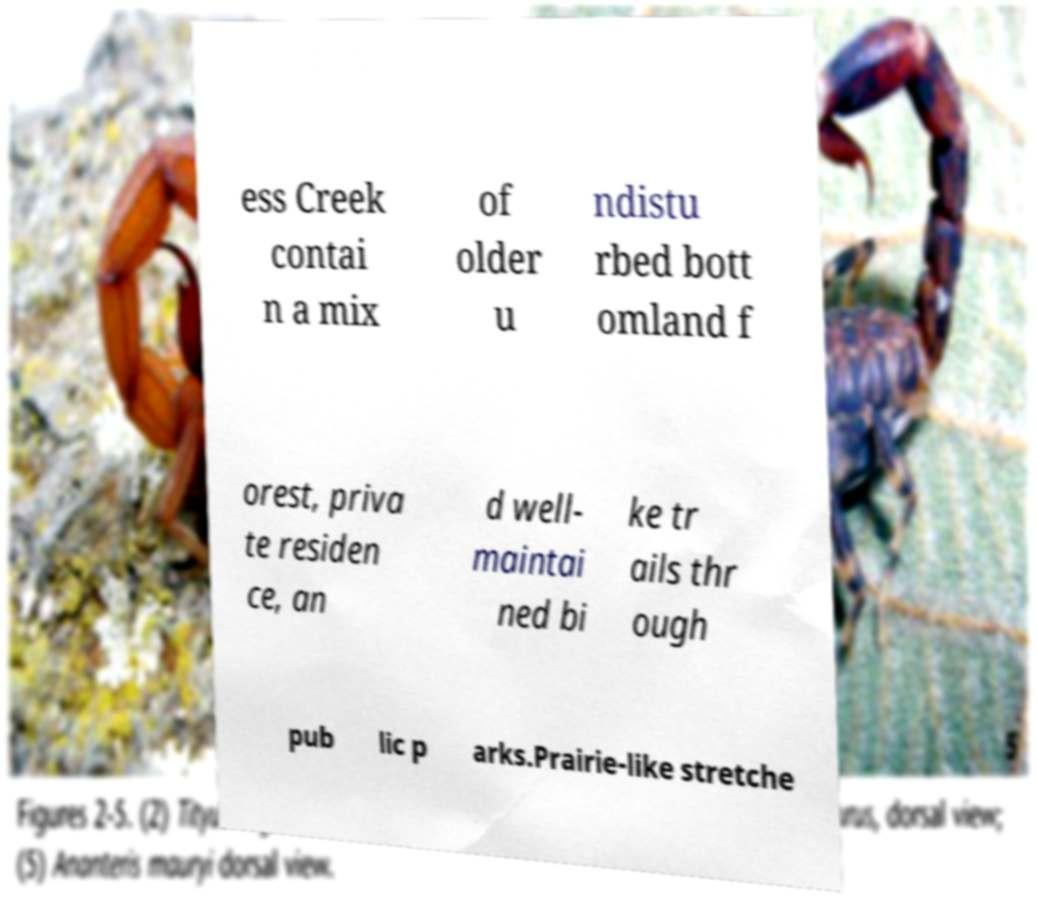Could you assist in decoding the text presented in this image and type it out clearly? ess Creek contai n a mix of older u ndistu rbed bott omland f orest, priva te residen ce, an d well- maintai ned bi ke tr ails thr ough pub lic p arks.Prairie-like stretche 